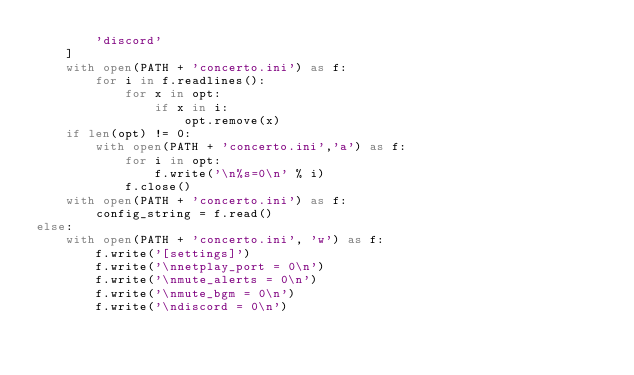Convert code to text. <code><loc_0><loc_0><loc_500><loc_500><_Python_>        'discord'
    ]
    with open(PATH + 'concerto.ini') as f:
        for i in f.readlines():
            for x in opt:
                if x in i:
                    opt.remove(x)
    if len(opt) != 0:
        with open(PATH + 'concerto.ini','a') as f:
            for i in opt:
                f.write('\n%s=0\n' % i)
            f.close()
    with open(PATH + 'concerto.ini') as f:
        config_string = f.read()
else:
    with open(PATH + 'concerto.ini', 'w') as f:
        f.write('[settings]')
        f.write('\nnetplay_port = 0\n')
        f.write('\nmute_alerts = 0\n')
        f.write('\nmute_bgm = 0\n')
        f.write('\ndiscord = 0\n')</code> 